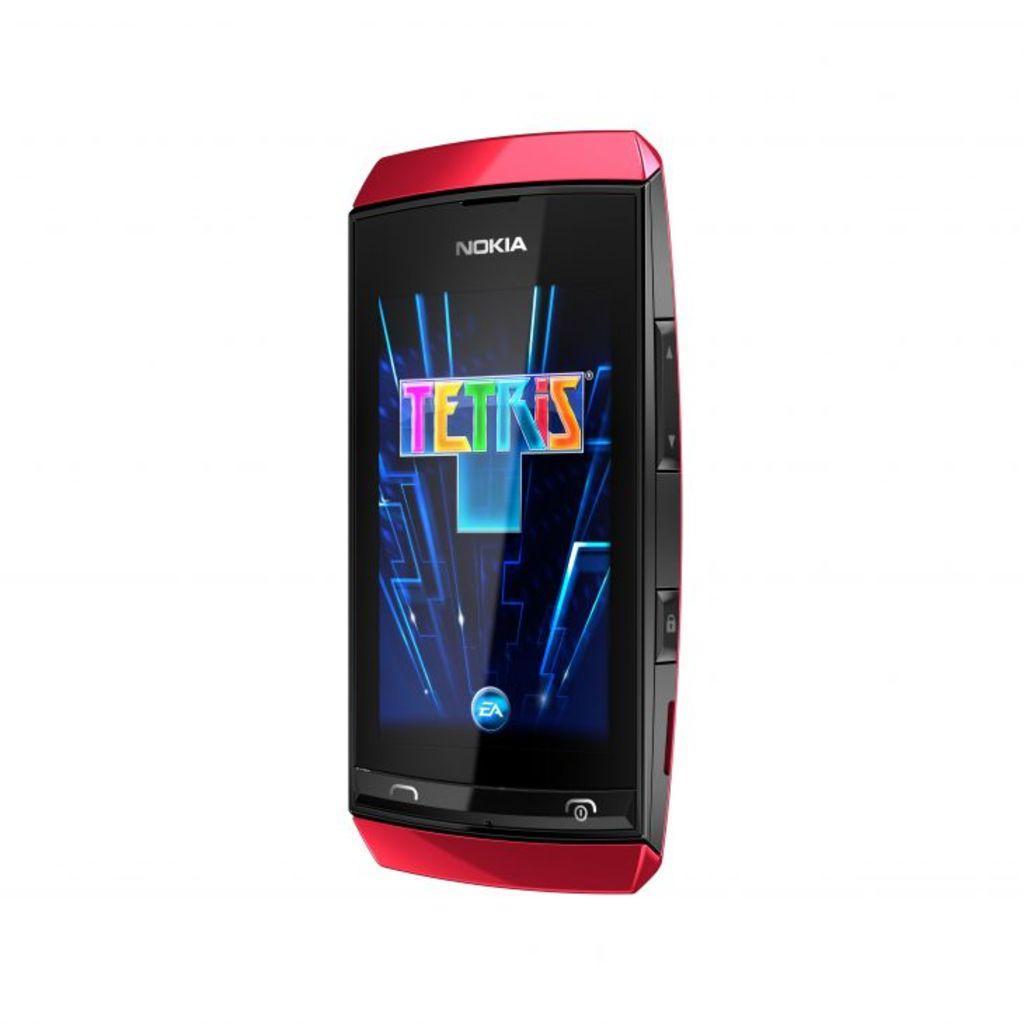Can you describe this image briefly? In this image I can see white color background and I can see a phone in the middle and top of the phone I can see colorful screen. 